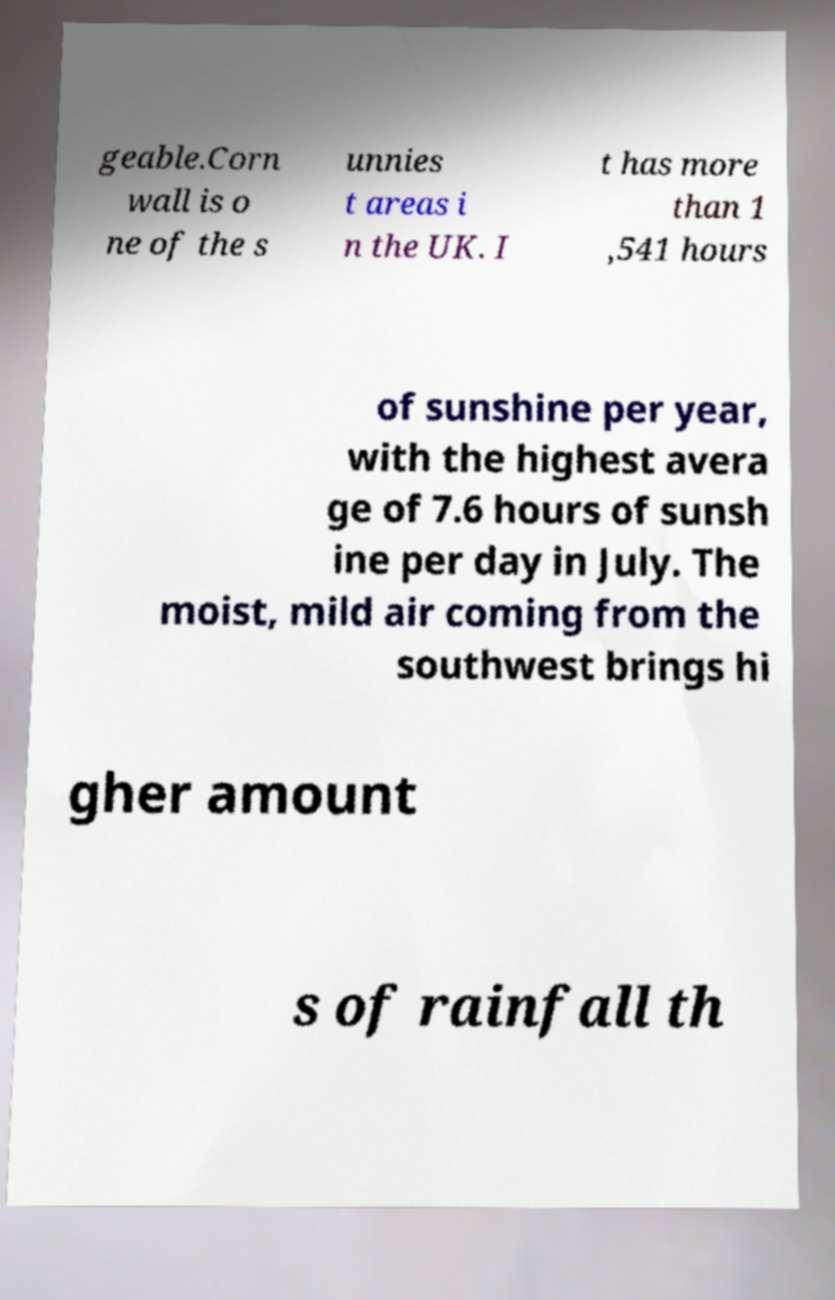Please identify and transcribe the text found in this image. geable.Corn wall is o ne of the s unnies t areas i n the UK. I t has more than 1 ,541 hours of sunshine per year, with the highest avera ge of 7.6 hours of sunsh ine per day in July. The moist, mild air coming from the southwest brings hi gher amount s of rainfall th 